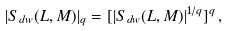<formula> <loc_0><loc_0><loc_500><loc_500>| S _ { d w } ( L , M ) | _ { q } = [ | S _ { d w } ( L , M ) | ^ { 1 / q } ] ^ { q } \, ,</formula> 